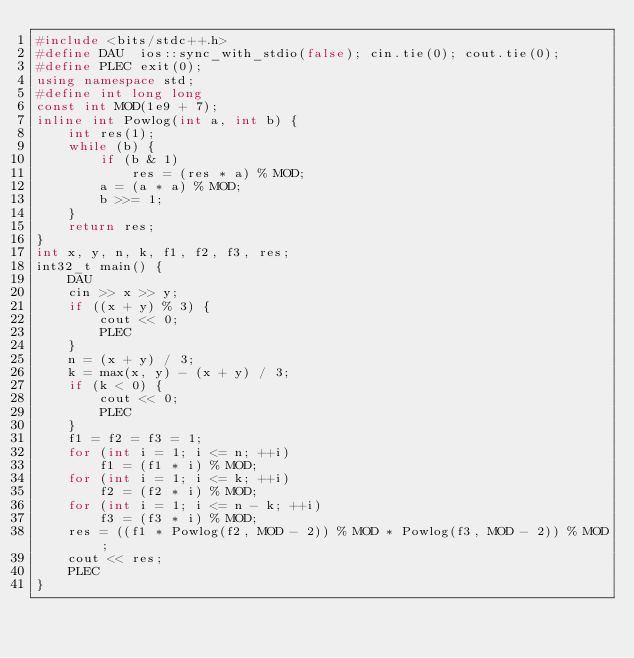<code> <loc_0><loc_0><loc_500><loc_500><_C++_>#include <bits/stdc++.h>
#define DAU  ios::sync_with_stdio(false); cin.tie(0); cout.tie(0);
#define PLEC exit(0);
using namespace std;
#define int long long
const int MOD(1e9 + 7);
inline int Powlog(int a, int b) {
    int res(1);
    while (b) {
        if (b & 1)
            res = (res * a) % MOD;
        a = (a * a) % MOD;
        b >>= 1;
    }
    return res;
}
int x, y, n, k, f1, f2, f3, res;
int32_t main() {
    DAU
    cin >> x >> y;
    if ((x + y) % 3) {
        cout << 0;
        PLEC
    }
    n = (x + y) / 3;
    k = max(x, y) - (x + y) / 3;
 	if (k < 0) {
    	cout << 0;
      	PLEC
    }
    f1 = f2 = f3 = 1;
    for (int i = 1; i <= n; ++i)
        f1 = (f1 * i) % MOD;
    for (int i = 1; i <= k; ++i)
        f2 = (f2 * i) % MOD;
    for (int i = 1; i <= n - k; ++i)
        f3 = (f3 * i) % MOD;
    res = ((f1 * Powlog(f2, MOD - 2)) % MOD * Powlog(f3, MOD - 2)) % MOD;
    cout << res;
    PLEC
}
</code> 